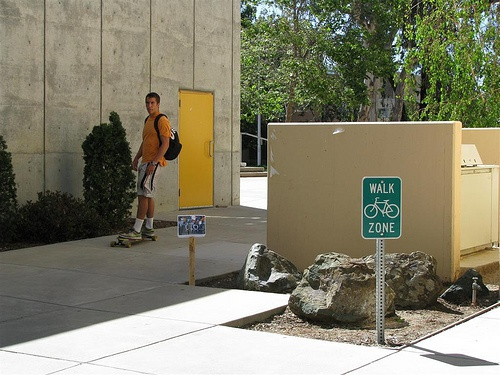Describe the objects in this image and their specific colors. I can see people in gray, maroon, and black tones, backpack in gray, black, and maroon tones, and skateboard in gray, black, and olive tones in this image. 